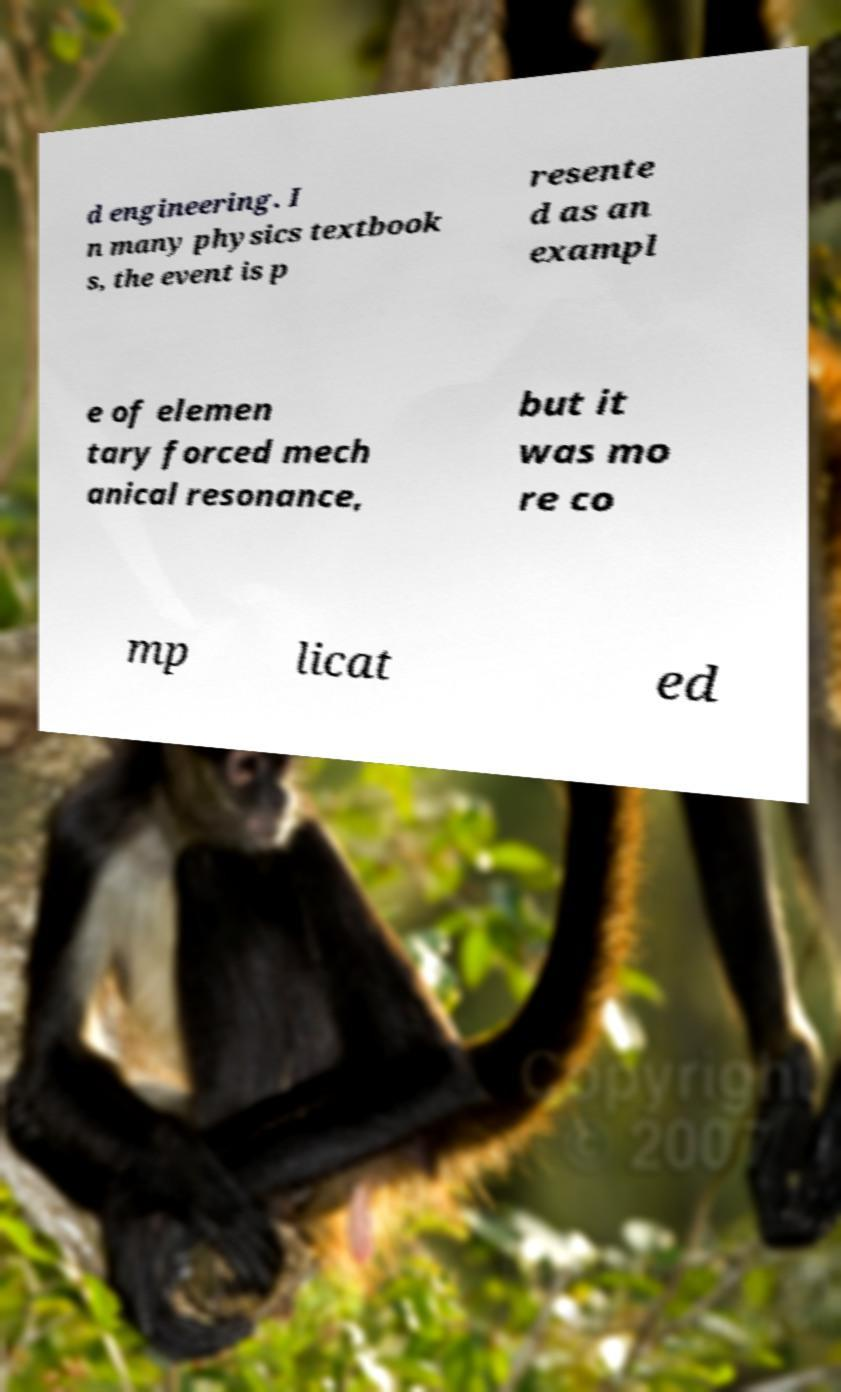There's text embedded in this image that I need extracted. Can you transcribe it verbatim? d engineering. I n many physics textbook s, the event is p resente d as an exampl e of elemen tary forced mech anical resonance, but it was mo re co mp licat ed 